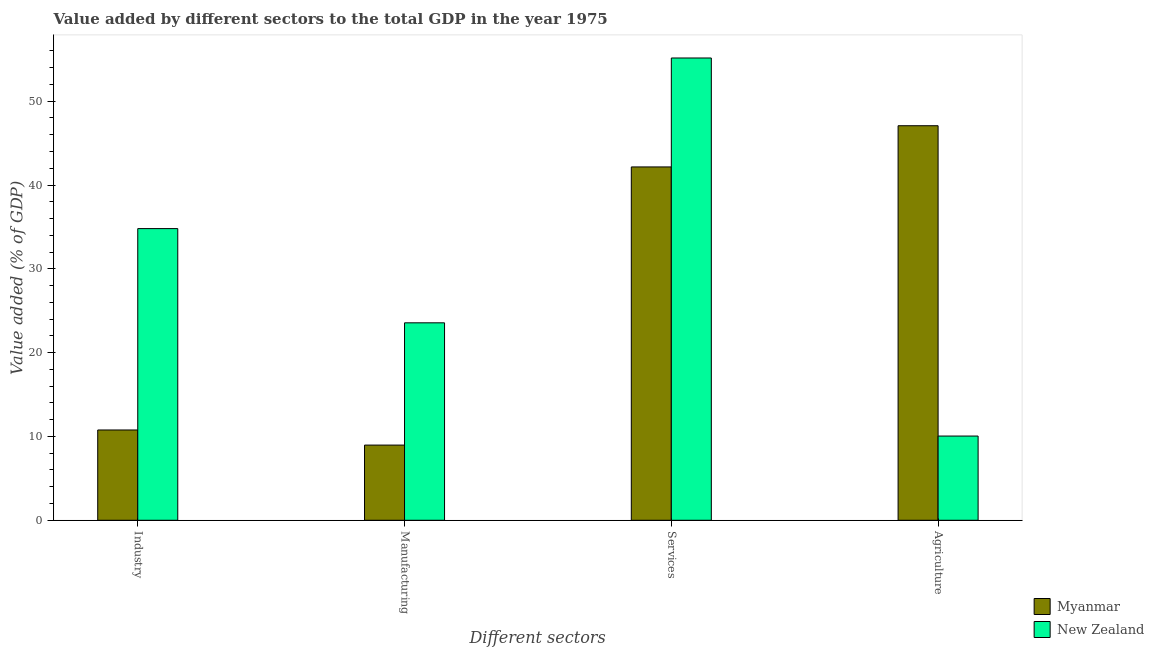Are the number of bars per tick equal to the number of legend labels?
Ensure brevity in your answer.  Yes. Are the number of bars on each tick of the X-axis equal?
Keep it short and to the point. Yes. What is the label of the 2nd group of bars from the left?
Give a very brief answer. Manufacturing. What is the value added by services sector in Myanmar?
Ensure brevity in your answer.  42.16. Across all countries, what is the maximum value added by industrial sector?
Keep it short and to the point. 34.8. Across all countries, what is the minimum value added by agricultural sector?
Your answer should be very brief. 10.05. In which country was the value added by industrial sector maximum?
Provide a succinct answer. New Zealand. In which country was the value added by agricultural sector minimum?
Offer a very short reply. New Zealand. What is the total value added by manufacturing sector in the graph?
Ensure brevity in your answer.  32.53. What is the difference between the value added by manufacturing sector in Myanmar and that in New Zealand?
Offer a very short reply. -14.59. What is the difference between the value added by industrial sector in New Zealand and the value added by manufacturing sector in Myanmar?
Your answer should be very brief. 25.83. What is the average value added by industrial sector per country?
Give a very brief answer. 22.79. What is the difference between the value added by services sector and value added by manufacturing sector in Myanmar?
Provide a succinct answer. 33.19. In how many countries, is the value added by services sector greater than 8 %?
Ensure brevity in your answer.  2. What is the ratio of the value added by manufacturing sector in New Zealand to that in Myanmar?
Give a very brief answer. 2.63. Is the difference between the value added by agricultural sector in New Zealand and Myanmar greater than the difference between the value added by industrial sector in New Zealand and Myanmar?
Ensure brevity in your answer.  No. What is the difference between the highest and the second highest value added by manufacturing sector?
Offer a terse response. 14.59. What is the difference between the highest and the lowest value added by agricultural sector?
Provide a succinct answer. 37.02. Is the sum of the value added by agricultural sector in New Zealand and Myanmar greater than the maximum value added by manufacturing sector across all countries?
Keep it short and to the point. Yes. What does the 1st bar from the left in Agriculture represents?
Provide a short and direct response. Myanmar. What does the 2nd bar from the right in Agriculture represents?
Your response must be concise. Myanmar. Is it the case that in every country, the sum of the value added by industrial sector and value added by manufacturing sector is greater than the value added by services sector?
Offer a terse response. No. How many legend labels are there?
Provide a succinct answer. 2. What is the title of the graph?
Your answer should be compact. Value added by different sectors to the total GDP in the year 1975. What is the label or title of the X-axis?
Ensure brevity in your answer.  Different sectors. What is the label or title of the Y-axis?
Your answer should be compact. Value added (% of GDP). What is the Value added (% of GDP) in Myanmar in Industry?
Your answer should be very brief. 10.77. What is the Value added (% of GDP) of New Zealand in Industry?
Give a very brief answer. 34.8. What is the Value added (% of GDP) in Myanmar in Manufacturing?
Make the answer very short. 8.97. What is the Value added (% of GDP) of New Zealand in Manufacturing?
Make the answer very short. 23.56. What is the Value added (% of GDP) of Myanmar in Services?
Ensure brevity in your answer.  42.16. What is the Value added (% of GDP) in New Zealand in Services?
Provide a succinct answer. 55.15. What is the Value added (% of GDP) in Myanmar in Agriculture?
Keep it short and to the point. 47.07. What is the Value added (% of GDP) of New Zealand in Agriculture?
Offer a terse response. 10.05. Across all Different sectors, what is the maximum Value added (% of GDP) of Myanmar?
Your answer should be compact. 47.07. Across all Different sectors, what is the maximum Value added (% of GDP) of New Zealand?
Your answer should be compact. 55.15. Across all Different sectors, what is the minimum Value added (% of GDP) of Myanmar?
Offer a terse response. 8.97. Across all Different sectors, what is the minimum Value added (% of GDP) in New Zealand?
Give a very brief answer. 10.05. What is the total Value added (% of GDP) of Myanmar in the graph?
Your answer should be very brief. 108.97. What is the total Value added (% of GDP) in New Zealand in the graph?
Keep it short and to the point. 123.56. What is the difference between the Value added (% of GDP) of Myanmar in Industry and that in Manufacturing?
Your answer should be compact. 1.8. What is the difference between the Value added (% of GDP) in New Zealand in Industry and that in Manufacturing?
Your answer should be very brief. 11.24. What is the difference between the Value added (% of GDP) in Myanmar in Industry and that in Services?
Ensure brevity in your answer.  -31.38. What is the difference between the Value added (% of GDP) in New Zealand in Industry and that in Services?
Offer a terse response. -20.36. What is the difference between the Value added (% of GDP) in Myanmar in Industry and that in Agriculture?
Your answer should be compact. -36.3. What is the difference between the Value added (% of GDP) of New Zealand in Industry and that in Agriculture?
Your answer should be compact. 24.75. What is the difference between the Value added (% of GDP) in Myanmar in Manufacturing and that in Services?
Keep it short and to the point. -33.19. What is the difference between the Value added (% of GDP) in New Zealand in Manufacturing and that in Services?
Your response must be concise. -31.6. What is the difference between the Value added (% of GDP) of Myanmar in Manufacturing and that in Agriculture?
Ensure brevity in your answer.  -38.1. What is the difference between the Value added (% of GDP) of New Zealand in Manufacturing and that in Agriculture?
Make the answer very short. 13.51. What is the difference between the Value added (% of GDP) of Myanmar in Services and that in Agriculture?
Make the answer very short. -4.92. What is the difference between the Value added (% of GDP) in New Zealand in Services and that in Agriculture?
Offer a terse response. 45.11. What is the difference between the Value added (% of GDP) in Myanmar in Industry and the Value added (% of GDP) in New Zealand in Manufacturing?
Your response must be concise. -12.78. What is the difference between the Value added (% of GDP) of Myanmar in Industry and the Value added (% of GDP) of New Zealand in Services?
Offer a very short reply. -44.38. What is the difference between the Value added (% of GDP) in Myanmar in Industry and the Value added (% of GDP) in New Zealand in Agriculture?
Your answer should be very brief. 0.72. What is the difference between the Value added (% of GDP) of Myanmar in Manufacturing and the Value added (% of GDP) of New Zealand in Services?
Offer a very short reply. -46.18. What is the difference between the Value added (% of GDP) of Myanmar in Manufacturing and the Value added (% of GDP) of New Zealand in Agriculture?
Provide a succinct answer. -1.08. What is the difference between the Value added (% of GDP) of Myanmar in Services and the Value added (% of GDP) of New Zealand in Agriculture?
Keep it short and to the point. 32.11. What is the average Value added (% of GDP) in Myanmar per Different sectors?
Keep it short and to the point. 27.24. What is the average Value added (% of GDP) of New Zealand per Different sectors?
Give a very brief answer. 30.89. What is the difference between the Value added (% of GDP) in Myanmar and Value added (% of GDP) in New Zealand in Industry?
Offer a terse response. -24.03. What is the difference between the Value added (% of GDP) of Myanmar and Value added (% of GDP) of New Zealand in Manufacturing?
Offer a very short reply. -14.59. What is the difference between the Value added (% of GDP) in Myanmar and Value added (% of GDP) in New Zealand in Services?
Ensure brevity in your answer.  -13. What is the difference between the Value added (% of GDP) in Myanmar and Value added (% of GDP) in New Zealand in Agriculture?
Provide a succinct answer. 37.02. What is the ratio of the Value added (% of GDP) in Myanmar in Industry to that in Manufacturing?
Offer a very short reply. 1.2. What is the ratio of the Value added (% of GDP) of New Zealand in Industry to that in Manufacturing?
Your answer should be compact. 1.48. What is the ratio of the Value added (% of GDP) of Myanmar in Industry to that in Services?
Keep it short and to the point. 0.26. What is the ratio of the Value added (% of GDP) of New Zealand in Industry to that in Services?
Your answer should be compact. 0.63. What is the ratio of the Value added (% of GDP) in Myanmar in Industry to that in Agriculture?
Your response must be concise. 0.23. What is the ratio of the Value added (% of GDP) of New Zealand in Industry to that in Agriculture?
Your answer should be compact. 3.46. What is the ratio of the Value added (% of GDP) of Myanmar in Manufacturing to that in Services?
Make the answer very short. 0.21. What is the ratio of the Value added (% of GDP) of New Zealand in Manufacturing to that in Services?
Provide a succinct answer. 0.43. What is the ratio of the Value added (% of GDP) in Myanmar in Manufacturing to that in Agriculture?
Provide a succinct answer. 0.19. What is the ratio of the Value added (% of GDP) in New Zealand in Manufacturing to that in Agriculture?
Your answer should be very brief. 2.34. What is the ratio of the Value added (% of GDP) of Myanmar in Services to that in Agriculture?
Offer a very short reply. 0.9. What is the ratio of the Value added (% of GDP) of New Zealand in Services to that in Agriculture?
Keep it short and to the point. 5.49. What is the difference between the highest and the second highest Value added (% of GDP) of Myanmar?
Your answer should be very brief. 4.92. What is the difference between the highest and the second highest Value added (% of GDP) in New Zealand?
Ensure brevity in your answer.  20.36. What is the difference between the highest and the lowest Value added (% of GDP) of Myanmar?
Your answer should be compact. 38.1. What is the difference between the highest and the lowest Value added (% of GDP) in New Zealand?
Your answer should be very brief. 45.11. 